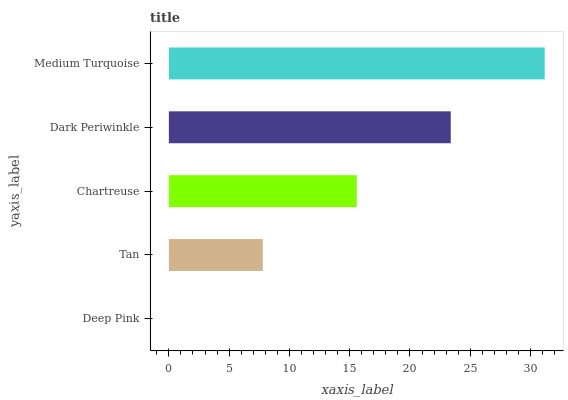Is Deep Pink the minimum?
Answer yes or no. Yes. Is Medium Turquoise the maximum?
Answer yes or no. Yes. Is Tan the minimum?
Answer yes or no. No. Is Tan the maximum?
Answer yes or no. No. Is Tan greater than Deep Pink?
Answer yes or no. Yes. Is Deep Pink less than Tan?
Answer yes or no. Yes. Is Deep Pink greater than Tan?
Answer yes or no. No. Is Tan less than Deep Pink?
Answer yes or no. No. Is Chartreuse the high median?
Answer yes or no. Yes. Is Chartreuse the low median?
Answer yes or no. Yes. Is Deep Pink the high median?
Answer yes or no. No. Is Tan the low median?
Answer yes or no. No. 